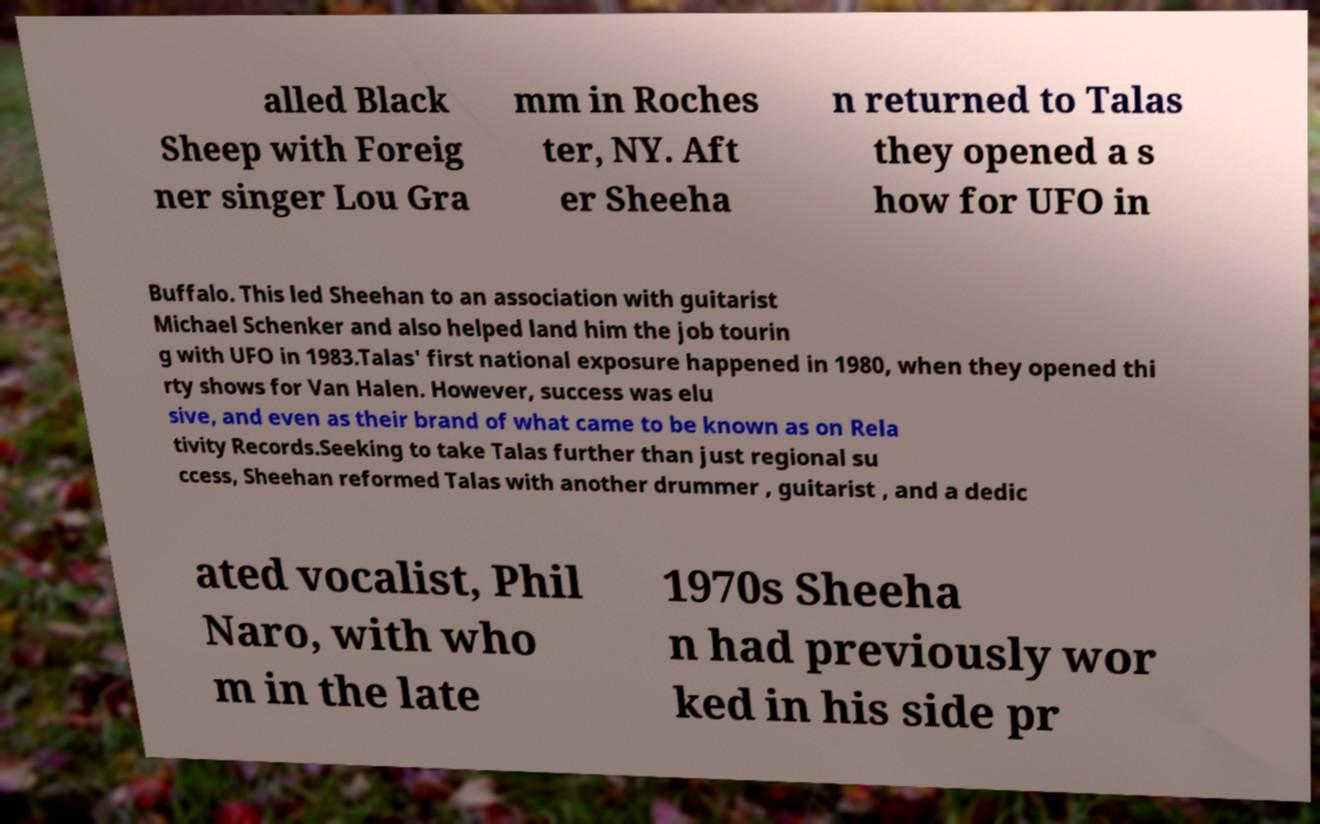Please identify and transcribe the text found in this image. alled Black Sheep with Foreig ner singer Lou Gra mm in Roches ter, NY. Aft er Sheeha n returned to Talas they opened a s how for UFO in Buffalo. This led Sheehan to an association with guitarist Michael Schenker and also helped land him the job tourin g with UFO in 1983.Talas' first national exposure happened in 1980, when they opened thi rty shows for Van Halen. However, success was elu sive, and even as their brand of what came to be known as on Rela tivity Records.Seeking to take Talas further than just regional su ccess, Sheehan reformed Talas with another drummer , guitarist , and a dedic ated vocalist, Phil Naro, with who m in the late 1970s Sheeha n had previously wor ked in his side pr 